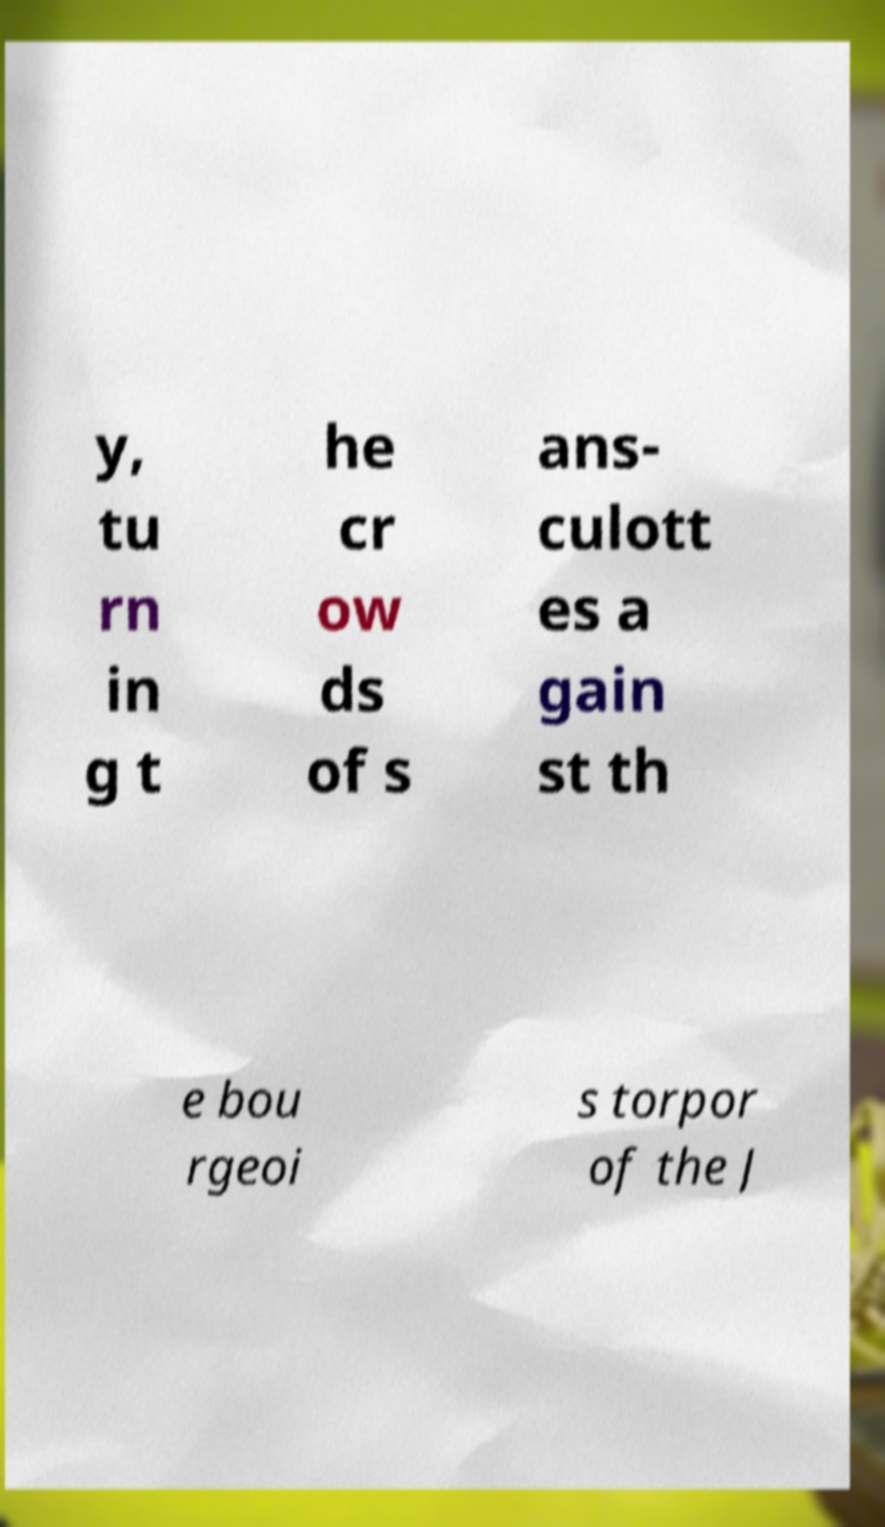For documentation purposes, I need the text within this image transcribed. Could you provide that? y, tu rn in g t he cr ow ds of s ans- culott es a gain st th e bou rgeoi s torpor of the J 